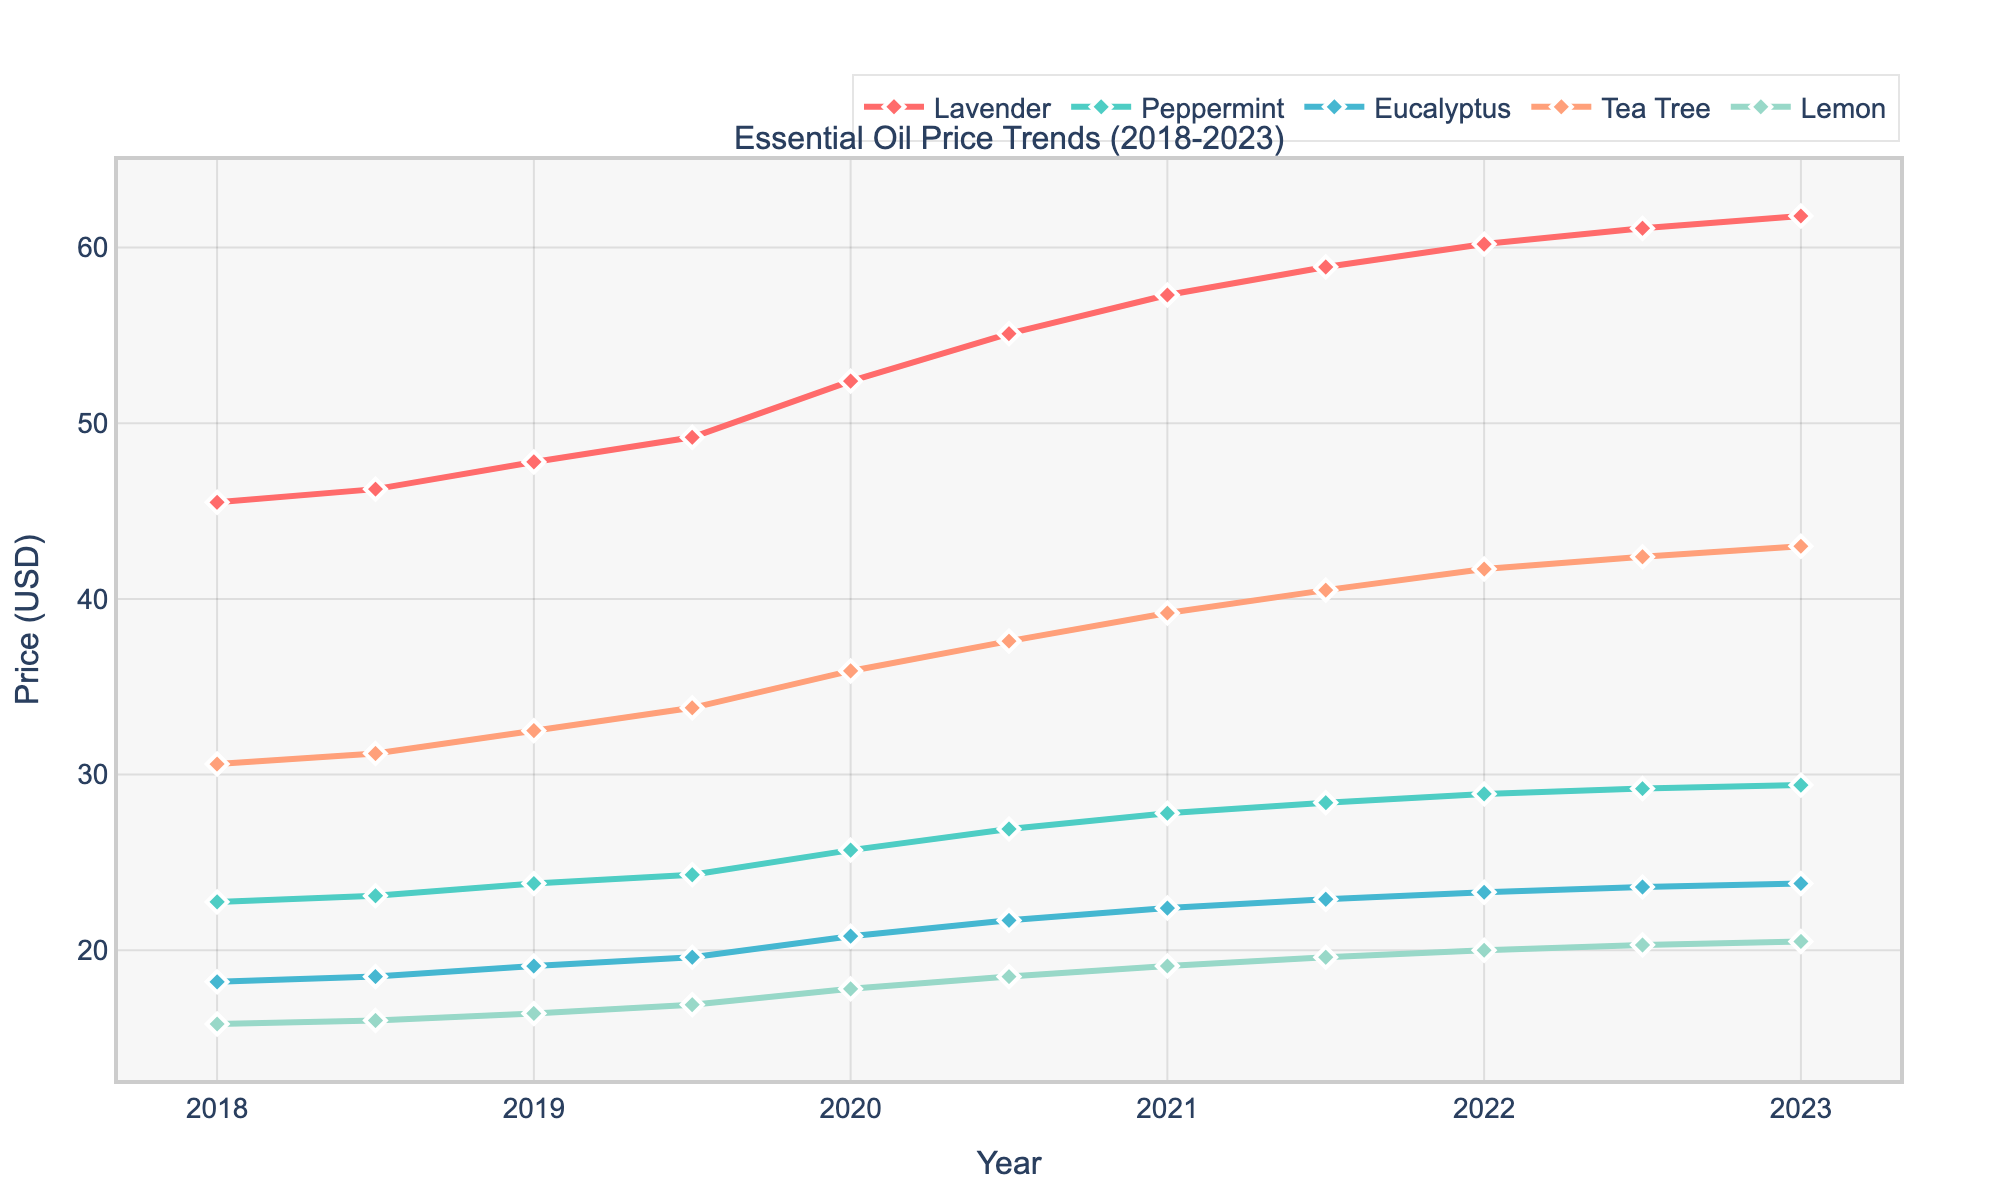What's the trend of Lavender prices from 2018 to 2023? From the line chart, observe that the line representing Lavender prices shows a steady upward trend from 2018 to 2023. The price starts at $45.50 in 2018 and reaches $61.80 in 2023.
Answer: Steady upward Which essential oil experienced the highest price increase over the five years? By examining the vertical difference from 2018 to 2023 for each essential oil line, we see that Lavender shows the greatest increase. Calculating the price differences: Lavender ($61.80 - $45.50) = $16.30, Peppermint ($29.40 - $22.75) = $6.65, Eucalyptus ($23.80 - $18.20) = $5.60, Tea Tree ($43.00 - $30.60) = $12.40, Lemon ($20.50 - $15.80) = $4.70. Thus, Lavender has the highest price increase.
Answer: Lavender What's the average price of Tea Tree oil in 2020? From the figure, we identify the prices for Tea Tree oil in 2020 at midpoint and endpoint: $35.90 (2020) and $37.60 (2020.5). The average of these two is (35.90 + 37.60) / 2 = 36.75.
Answer: 36.75 Which essential oil was consistently the cheapest in all years shown? By visually examining the lowest points of each line over the entire period, Lemon consistently appears at the bottom, indicating it had the lowest prices every year from 2018 to 2023.
Answer: Lemon Was there any year when Peppermint oil price dropped, or did it always increase? Review the Peppermint line on the graph. It starts at $22.75 in 2018 and ends at $29.40 in 2023, strictly increasing each year. There are no dips observed.
Answer: Always increase What is the price difference between the most expensive and least expensive oil in 2021? By checking the endpoint prices for 2021, the most expensive is Lavender at $57.30, and the least expensive is Lemon at $19.10. The difference is $57.30 - $19.10 = $38.20.
Answer: 38.20 How did Eucalyptus oil prices change between the first and last measured points? Refer to Eucalyptus's price in 2018 ($18.20) and 2023 ($23.80). The price increased over the period. The difference is $23.80 - $18.20 = $5.60.
Answer: Increased by $5.60 Which two essential oils had their prices converge the most in 2022.5? By looking closely at the intersection points or closely-aligned lines at 2022.5, Peppermint ($29.20) and Eucalyptus ($23.60) are closest. The difference is $29.20 - $23.60 = $5.60, which is the smallest compared to other pairs.
Answer: Peppermint and Eucalyptus What is the overall percentage increase in Tea Tree oil prices from 2018 to 2023? For Tea Tree oil, the price in 2018 was $30.60, and in 2023 it is $43.00. The percentage increase is calculated as ((43.00 - 30.60) / 30.60) * 100 = 40.52%.
Answer: 40.52% What's the combined price of Lemon and Peppermint oils in 2020.5? Identify the prices of Lemon ($18.50) and Peppermint ($26.90) in 2020.5. Summing these values gives $18.50 + $26.90 = $45.40.
Answer: 45.40 